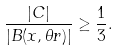<formula> <loc_0><loc_0><loc_500><loc_500>\frac { | C | } { | B ( x , \theta r ) | } \geq \frac { 1 } { 3 } .</formula> 